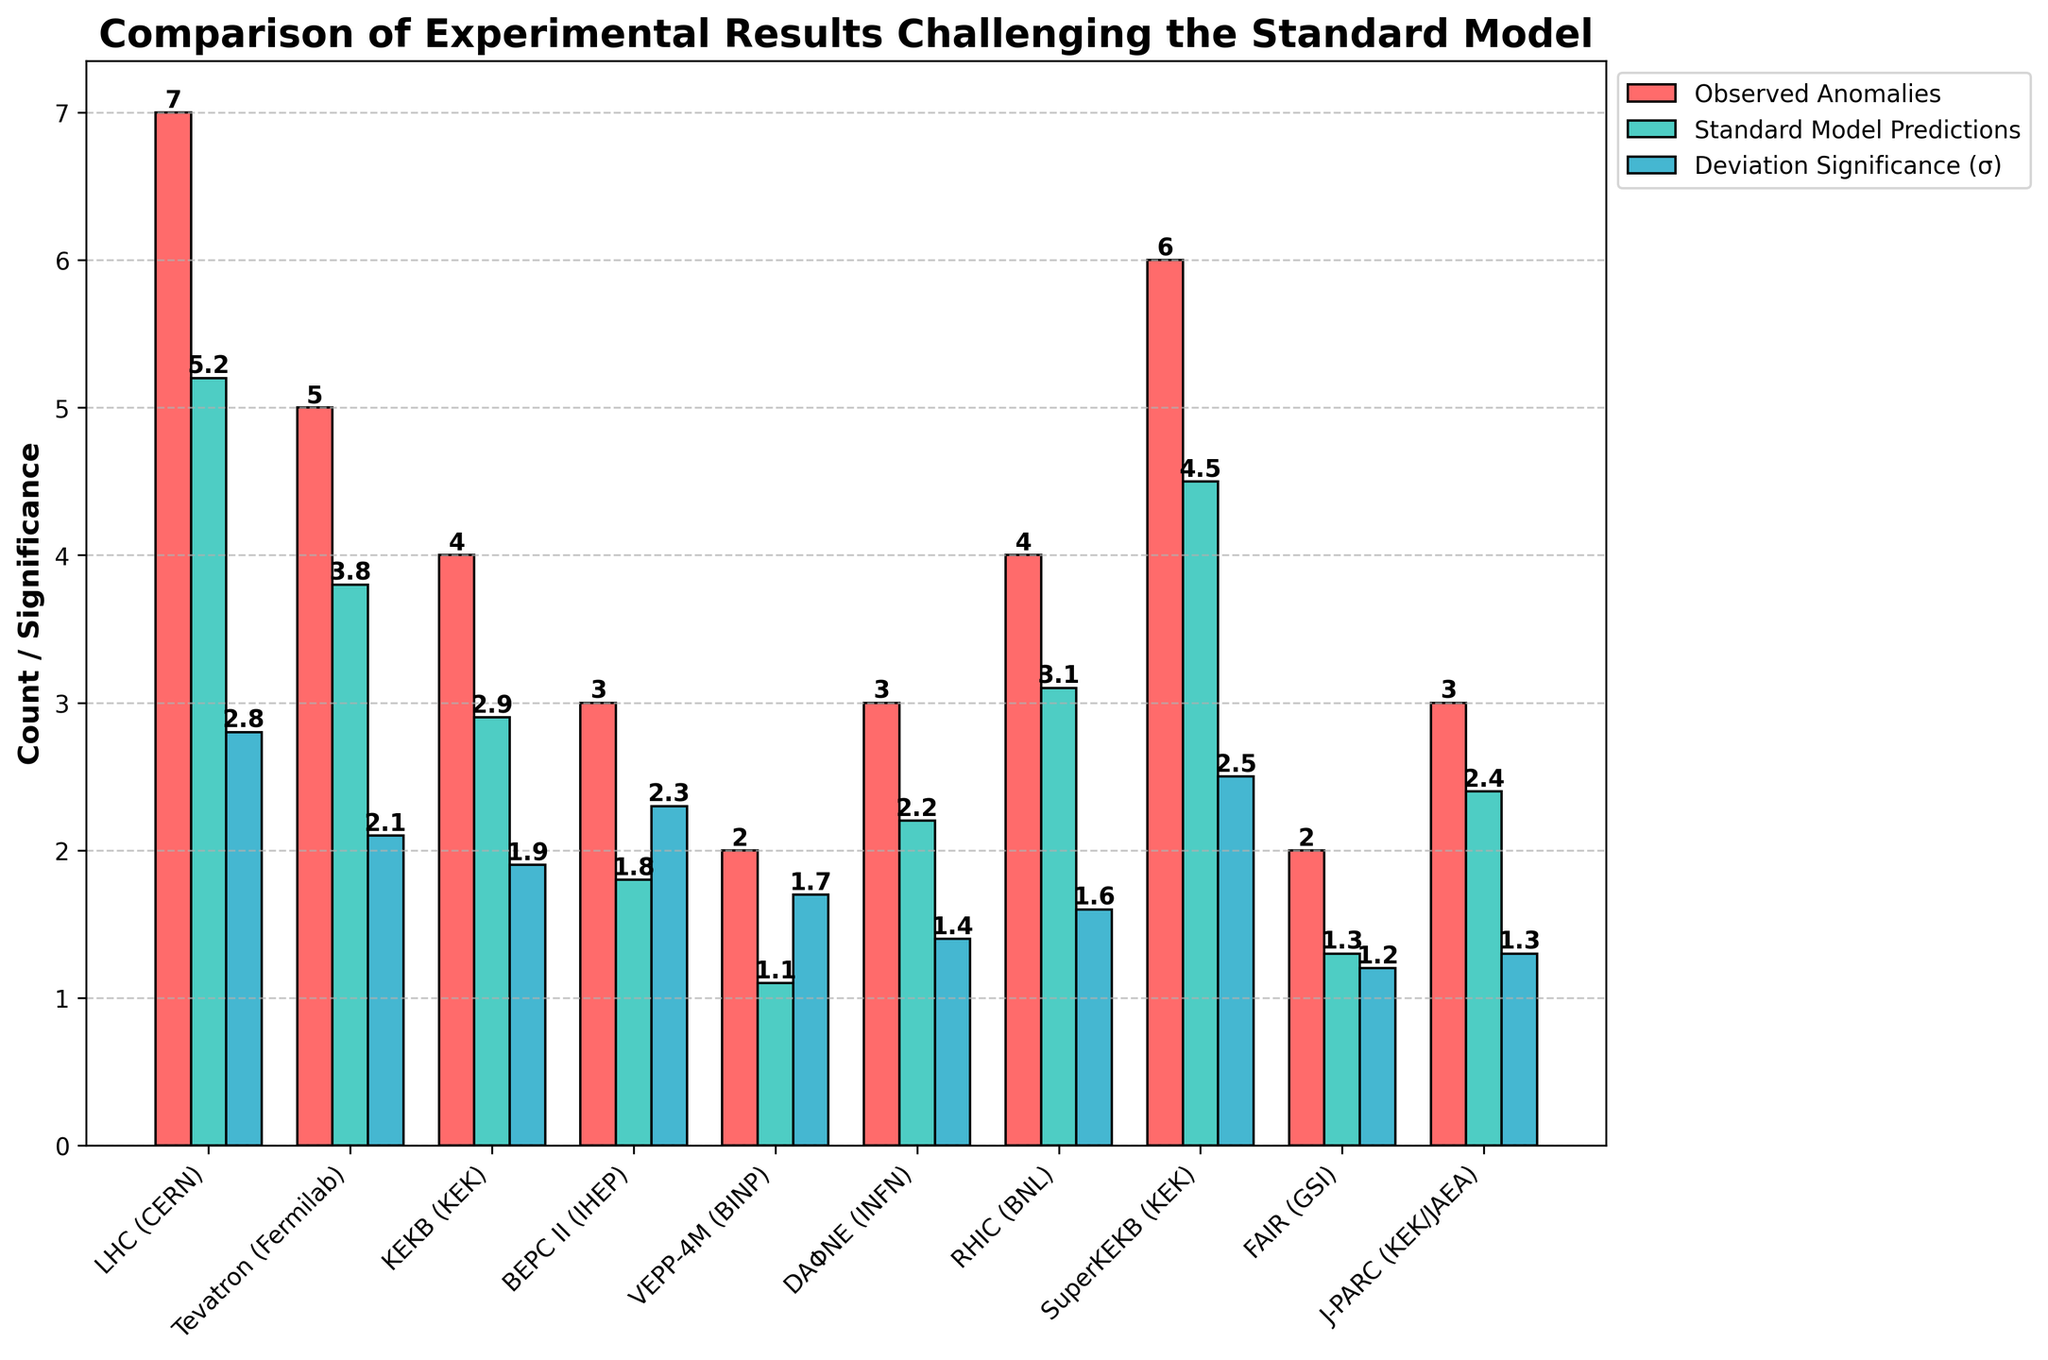Which accelerator shows the highest deviation significance in sigma? To find the accelerator with the highest deviation significance, look for the tallest blue bar in the 'Deviation Significance (σ)' category. The LHC (CERN) has the tallest blue bar, indicating 2.8 sigma.
Answer: LHC (CERN) Which two accelerators have exactly 3 observed anomalies? Look for the red bars representing 'Observed Anomalies' that have a height of 3. BEPC II (IHEP) and DAΦNE (INFN) both have red bars indicating 3 anomalies.
Answer: BEPC II (IHEP), DAΦNE (INFN) What is the total number of observed anomalies across all accelerators? Sum up the red bar values for 'Observed Anomalies' from all accelerators: 7+5+4+3+2+3+4+6+2+3 = 39 anomalies.
Answer: 39 Which accelerator has the smallest deviation significance in sigma, and what is its value? Identify the shortest blue bar in the 'Deviation Significance (σ)' category. FAIR (GSI) has the shortest blue bar, showing a deviation significance of 1.2 sigma.
Answer: FAIR (GSI), 1.2 Compare the observed anomalies and standard model predictions for SuperKEKB (KEK). Are they close to each other? Check the heights of the red and green bars for SuperKEKB (KEK). The observed anomalies are 6 and the standard model predictions are 4.5, indicating they are not very close.
Answer: No, they are not close Which accelerator has a higher deviation significance: KEKB (KEK) or RHIC (BNL)? Compare the blue bars for KEKB (KEK) and RHIC (BNL). KEKB (KEK) has a deviation significance of 1.9, while RHIC (BNL) has 1.6. KEKB (KEK) is higher.
Answer: KEKB (KEK) Between LHC (CERN) and Tevatron (Fermilab), which one has more observed anomalies than standard model predictions, and by how much? Compare the red and green bars for LHC (CERN) and Tevatron (Fermilab). LHC (CERN) has 1.8 more anomalies (7 - 5.2), while Tevatron (Fermilab) has 1.2 more (5 - 3.8). LHC (CERN) has more by 1.8 anomalies.
Answer: LHC (CERN), by 1.8 anomalies 